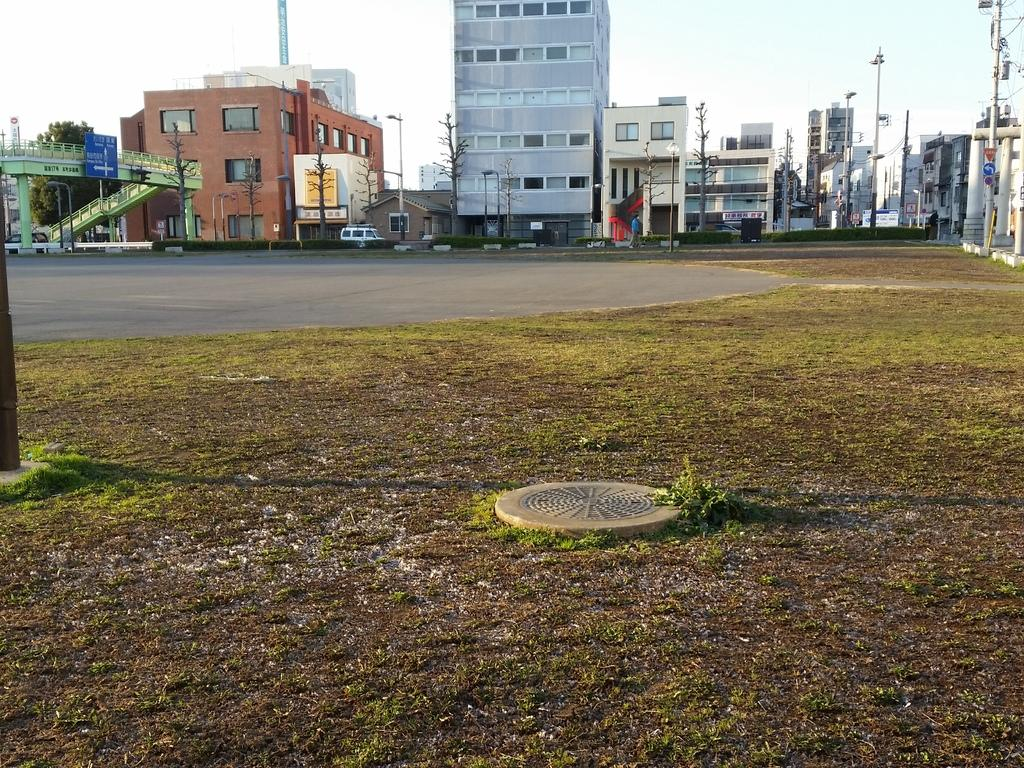What type of surface can be seen in the image? There is ground visible in the image. What type of vegetation is present in the image? There is grass in the image. What type of infrastructure is present in the image? There is a manhole lid and a road in the image. What can be seen in the background of the image? There are trees, buildings, metal poles, and the sky visible in the background of the image. What is the man using to support his chin in the image? There is no man or chin present in the image. What type of food is being served for lunch in the image? There is no mention of food or lunch in the image. 